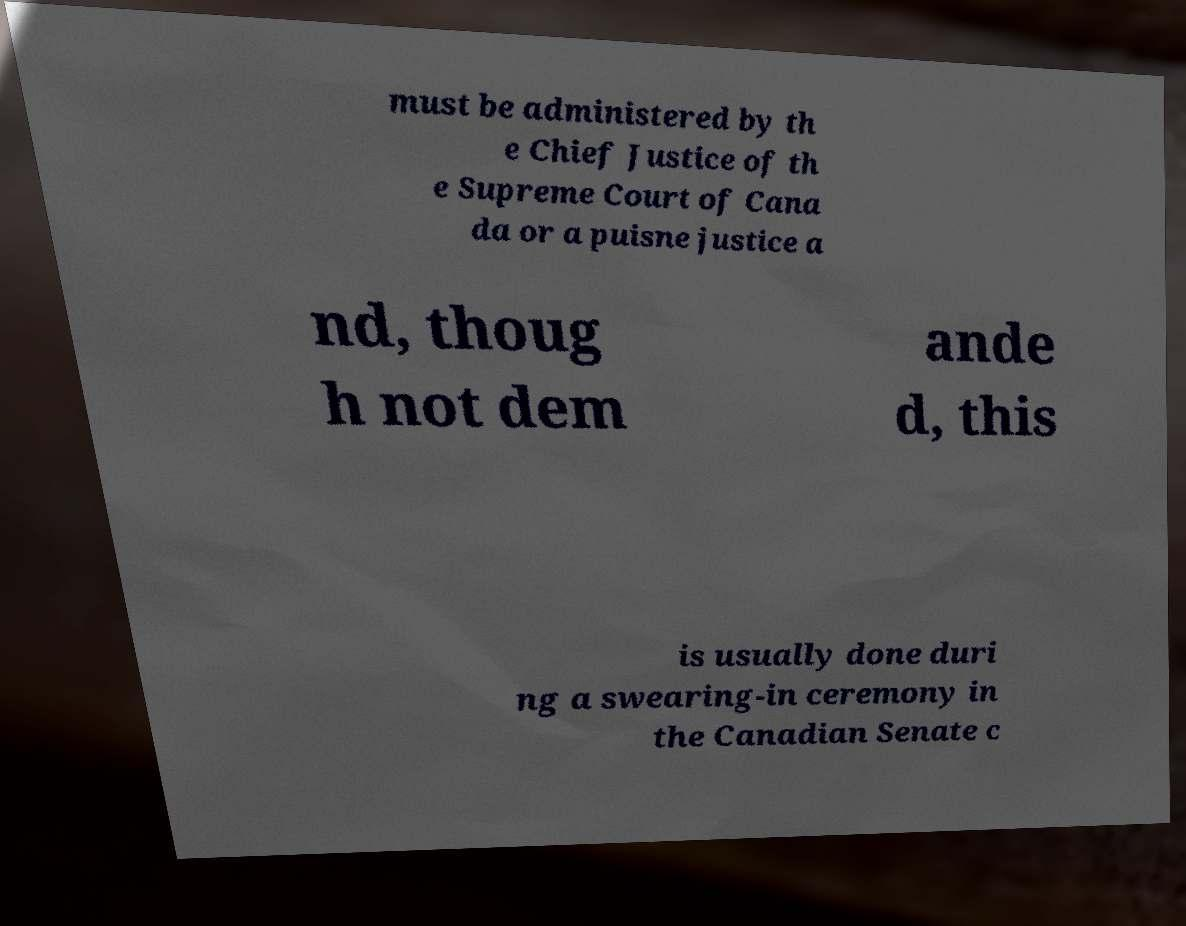There's text embedded in this image that I need extracted. Can you transcribe it verbatim? must be administered by th e Chief Justice of th e Supreme Court of Cana da or a puisne justice a nd, thoug h not dem ande d, this is usually done duri ng a swearing-in ceremony in the Canadian Senate c 